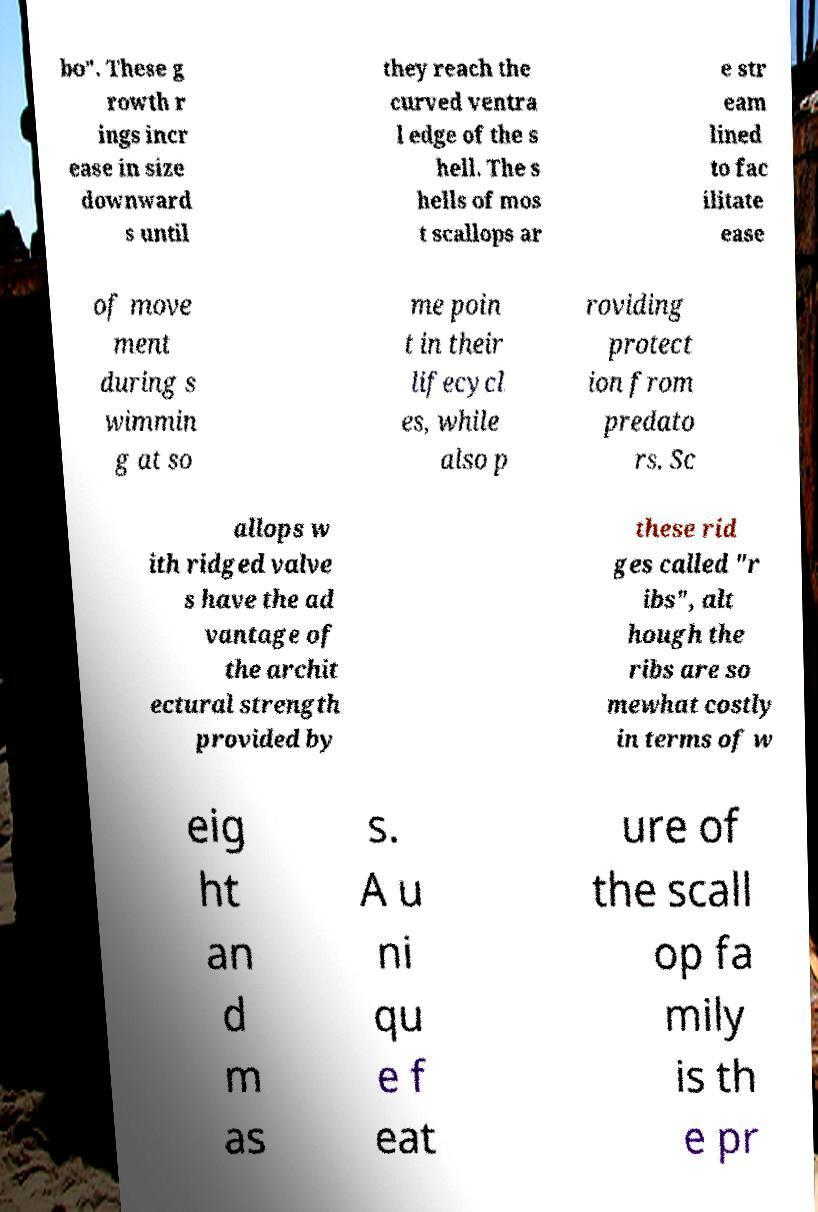Please read and relay the text visible in this image. What does it say? bo". These g rowth r ings incr ease in size downward s until they reach the curved ventra l edge of the s hell. The s hells of mos t scallops ar e str eam lined to fac ilitate ease of move ment during s wimmin g at so me poin t in their lifecycl es, while also p roviding protect ion from predato rs. Sc allops w ith ridged valve s have the ad vantage of the archit ectural strength provided by these rid ges called "r ibs", alt hough the ribs are so mewhat costly in terms of w eig ht an d m as s. A u ni qu e f eat ure of the scall op fa mily is th e pr 